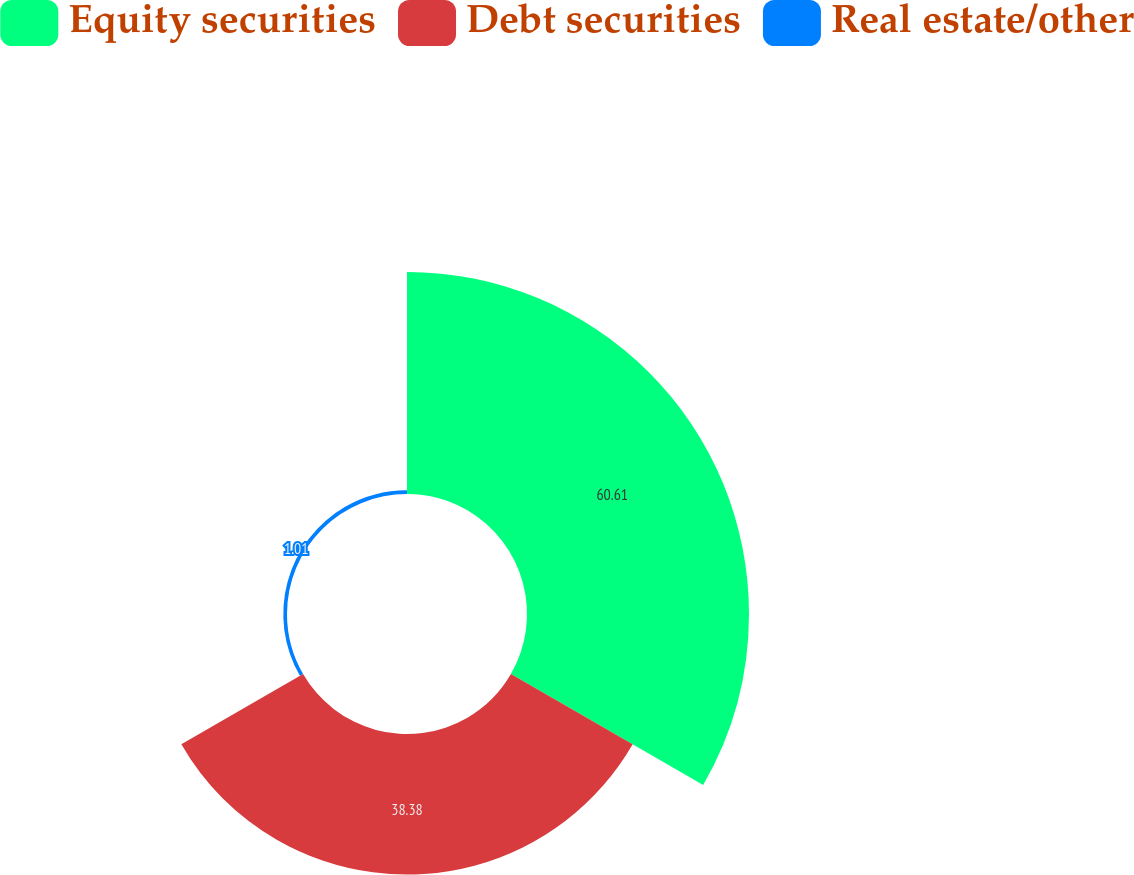<chart> <loc_0><loc_0><loc_500><loc_500><pie_chart><fcel>Equity securities<fcel>Debt securities<fcel>Real estate/other<nl><fcel>60.61%<fcel>38.38%<fcel>1.01%<nl></chart> 